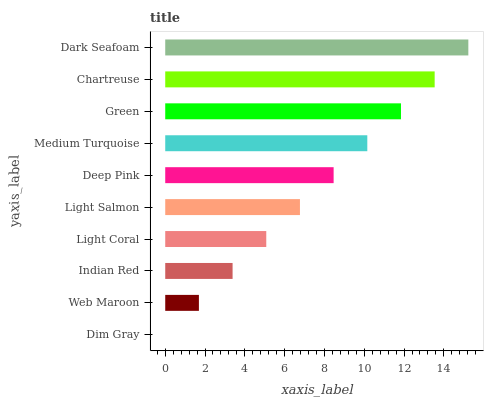Is Dim Gray the minimum?
Answer yes or no. Yes. Is Dark Seafoam the maximum?
Answer yes or no. Yes. Is Web Maroon the minimum?
Answer yes or no. No. Is Web Maroon the maximum?
Answer yes or no. No. Is Web Maroon greater than Dim Gray?
Answer yes or no. Yes. Is Dim Gray less than Web Maroon?
Answer yes or no. Yes. Is Dim Gray greater than Web Maroon?
Answer yes or no. No. Is Web Maroon less than Dim Gray?
Answer yes or no. No. Is Deep Pink the high median?
Answer yes or no. Yes. Is Light Salmon the low median?
Answer yes or no. Yes. Is Dim Gray the high median?
Answer yes or no. No. Is Web Maroon the low median?
Answer yes or no. No. 